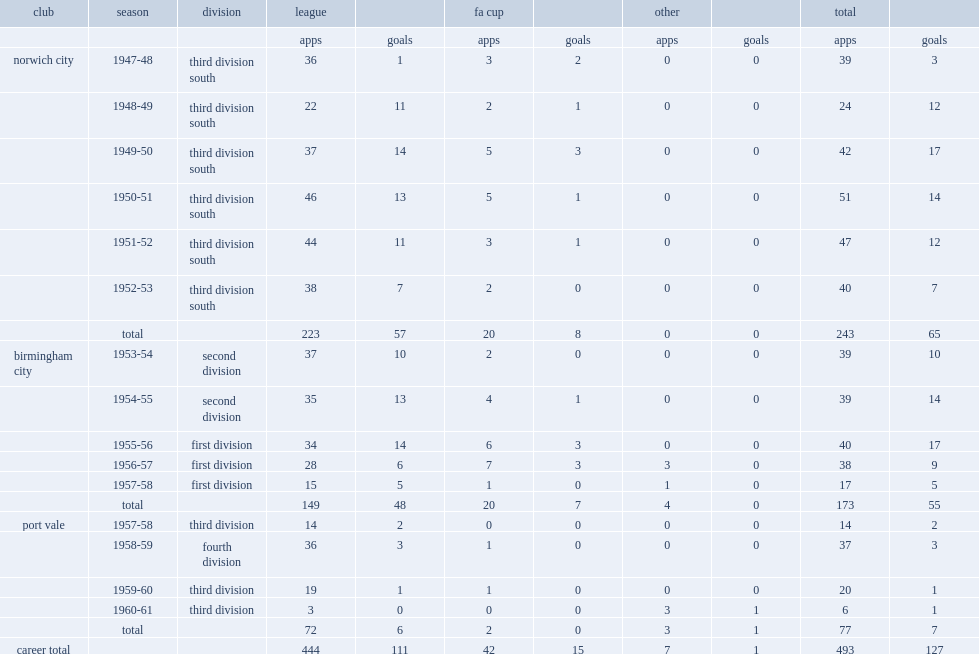How many league goals did noel kinsey score for norwich city totally? 57.0. Would you mind parsing the complete table? {'header': ['club', 'season', 'division', 'league', '', 'fa cup', '', 'other', '', 'total', ''], 'rows': [['', '', '', 'apps', 'goals', 'apps', 'goals', 'apps', 'goals', 'apps', 'goals'], ['norwich city', '1947-48', 'third division south', '36', '1', '3', '2', '0', '0', '39', '3'], ['', '1948-49', 'third division south', '22', '11', '2', '1', '0', '0', '24', '12'], ['', '1949-50', 'third division south', '37', '14', '5', '3', '0', '0', '42', '17'], ['', '1950-51', 'third division south', '46', '13', '5', '1', '0', '0', '51', '14'], ['', '1951-52', 'third division south', '44', '11', '3', '1', '0', '0', '47', '12'], ['', '1952-53', 'third division south', '38', '7', '2', '0', '0', '0', '40', '7'], ['', 'total', '', '223', '57', '20', '8', '0', '0', '243', '65'], ['birmingham city', '1953-54', 'second division', '37', '10', '2', '0', '0', '0', '39', '10'], ['', '1954-55', 'second division', '35', '13', '4', '1', '0', '0', '39', '14'], ['', '1955-56', 'first division', '34', '14', '6', '3', '0', '0', '40', '17'], ['', '1956-57', 'first division', '28', '6', '7', '3', '3', '0', '38', '9'], ['', '1957-58', 'first division', '15', '5', '1', '0', '1', '0', '17', '5'], ['', 'total', '', '149', '48', '20', '7', '4', '0', '173', '55'], ['port vale', '1957-58', 'third division', '14', '2', '0', '0', '0', '0', '14', '2'], ['', '1958-59', 'fourth division', '36', '3', '1', '0', '0', '0', '37', '3'], ['', '1959-60', 'third division', '19', '1', '1', '0', '0', '0', '20', '1'], ['', '1960-61', 'third division', '3', '0', '0', '0', '3', '1', '6', '1'], ['', 'total', '', '72', '6', '2', '0', '3', '1', '77', '7'], ['career total', '', '', '444', '111', '42', '15', '7', '1', '493', '127']]} 